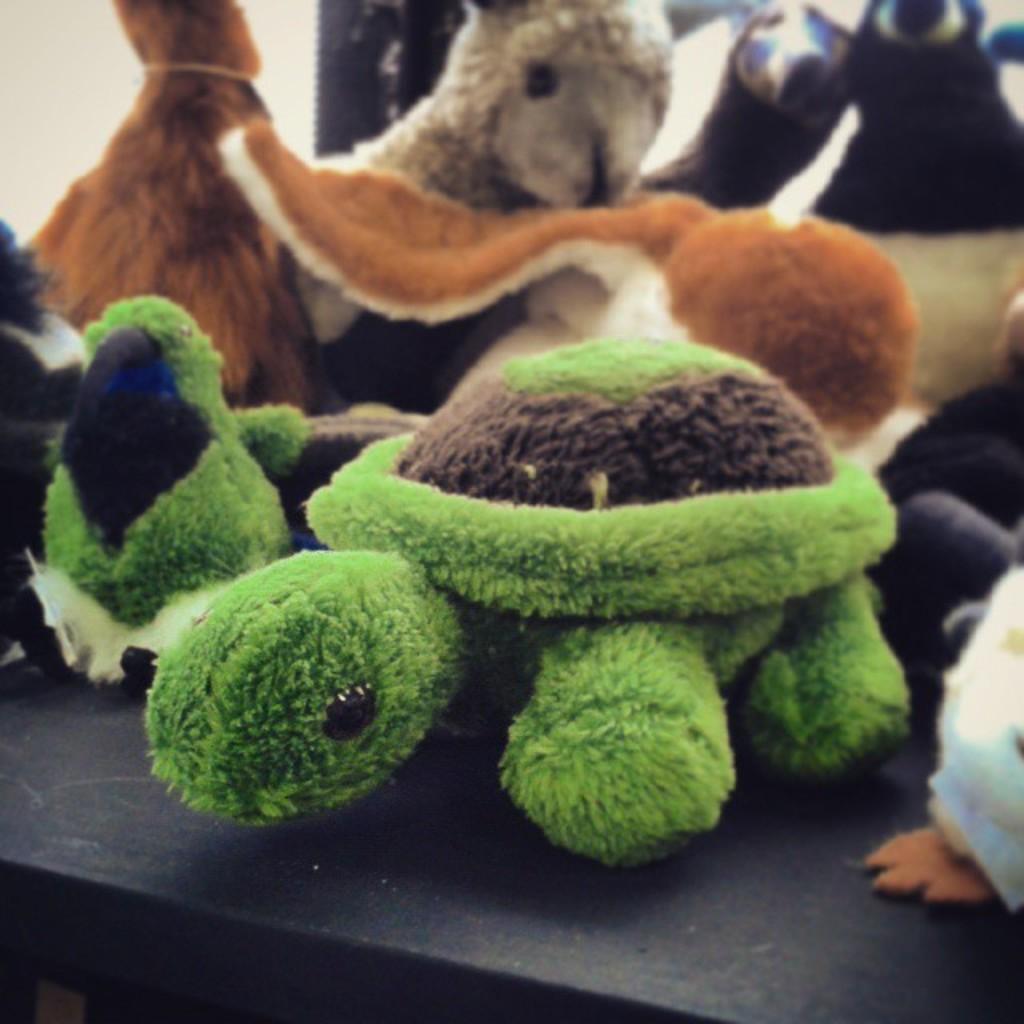Could you give a brief overview of what you see in this image? In this image I see number of soft toys which are colorful and I see the black color surface. 